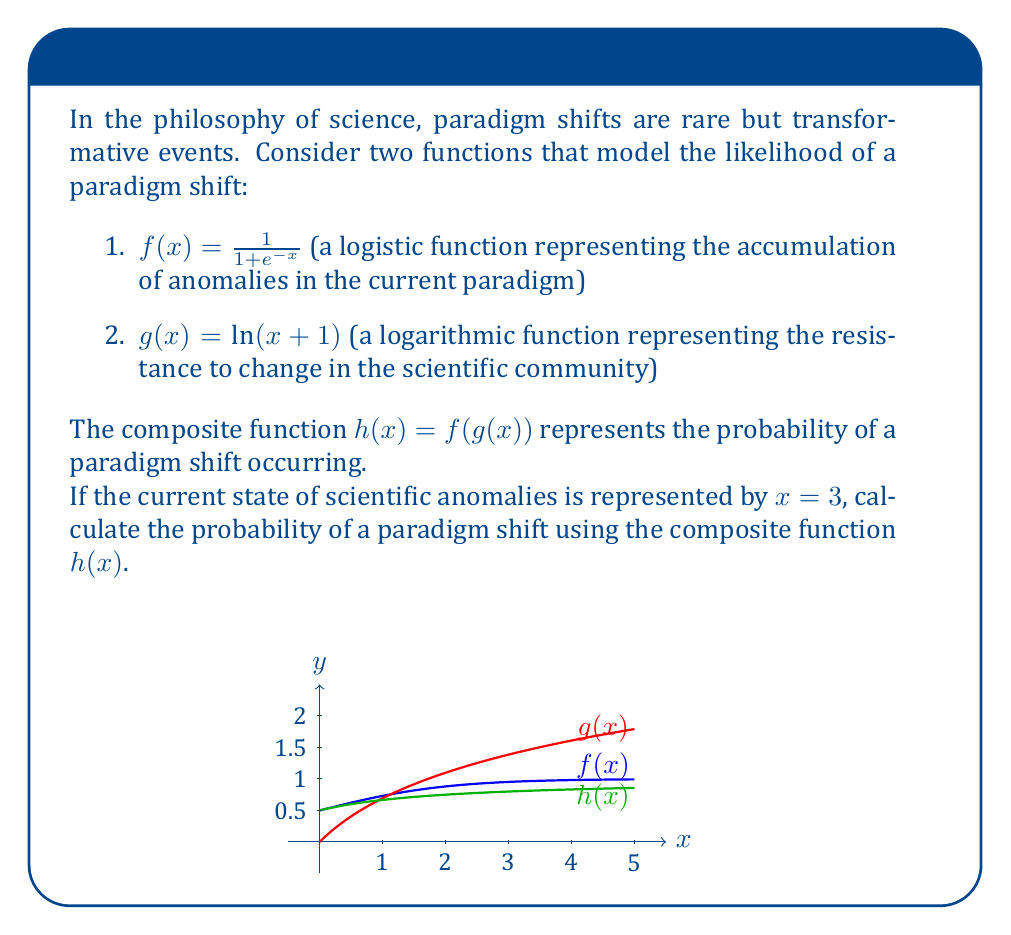Could you help me with this problem? Let's approach this step-by-step:

1) We need to calculate $h(3) = f(g(3))$

2) First, let's calculate $g(3)$:
   $g(3) = \ln(3 + 1) = \ln(4) = 1.386$ (rounded to 3 decimal places)

3) Now we need to calculate $f(1.386)$:
   $f(1.386) = \frac{1}{1 + e^{-1.386}}$

4) Let's calculate this:
   $e^{-1.386} \approx 0.250$ (rounded to 3 decimal places)
   
   $1 + e^{-1.386} \approx 1.250$
   
   $\frac{1}{1 + e^{-1.386}} \approx \frac{1}{1.250} = 0.800$

5) Therefore, $h(3) = f(g(3)) \approx 0.800$

This result can be interpreted as an 80% probability of a paradigm shift occurring given the current state of scientific anomalies.

This approach aligns with Thomas Kuhn's philosophy of scientific revolutions, where paradigm shifts occur when anomalies accumulate to a critical point, overcoming the scientific community's resistance to change.
Answer: $h(3) \approx 0.800$ or 80% 